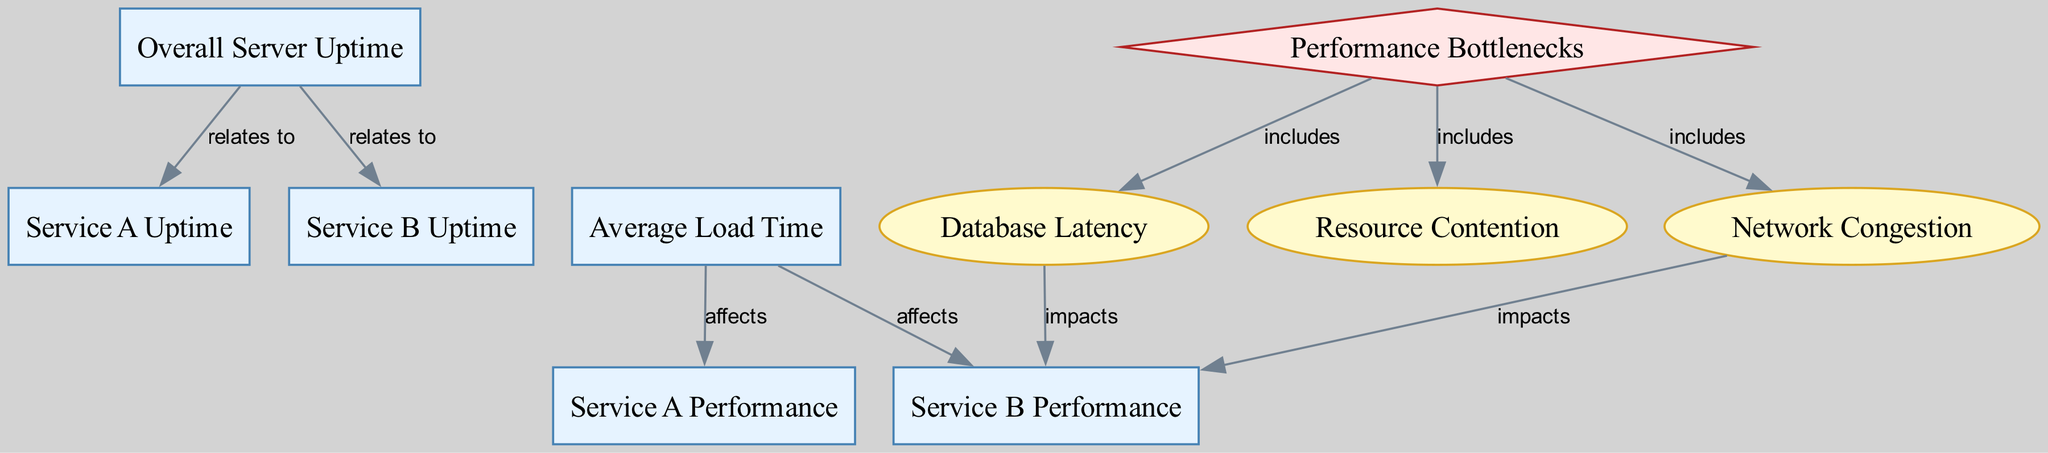What is the uptime percentage for Service A? The diagram contains a node labeled "Service A Uptime," which represents the uptime percentage specifically for Service A. This information can be directly identified from the node itself.
Answer: Service A Uptime What is overall server uptime? The "Overall Server Uptime" node provides the percentage of time the server is operational. The value for this metric can be found directly in the node labeled "Overall Server Uptime."
Answer: Overall Server Uptime How many performance bottlenecks are identified? The section "Performance Bottlenecks" has three identified issues that fall under it: Database Latency, Resource Contention, and Network Congestion. Therefore, the count of performance bottlenecks is determined by the number of issues listed.
Answer: Three Which service has a performance impacted by database latency? The diagram shows that "Database Latency" impacts "Service B Performance" as represented by the directed edge labeled "impacts". Thus, the description indicates that database latency affects the performance metrics for Service B.
Answer: Service B What is the relationship between average load time and Service A performance? There is an edge labeled "affects" connecting the "Average Load Time" node to the "Service A Performance" node. This indicates that the average load time directly affects the average response time for Service A.
Answer: Affects Which issue is related to network delays? The node labeled "Network Congestion" directly corresponds to the identified issue causing delays. It is explicitly outlined in the diagram, showing its role in impacting performance.
Answer: Network Congestion How many nodes represent performance metrics? The diagram contains five nodes that serve as performance metrics: "Overall Server Uptime," "Service A Uptime," "Service B Uptime," "Average Load Time," "Service A Performance," and "Service B Performance." To find the total, one counts these specific nodes.
Answer: Five What is the effect of resource contention on service performance? "Resource Contention" is identified as an issue in the diagram and impacts "Service B Performance" based on the directed edge labeled "impacts." This shows that resource contention leads to performance degradation for Service B.
Answer: Service B Performance Which services are directly related to overall server uptime? The diagram depicts edges connecting "Overall Server Uptime" to both "Service A Uptime" and "Service B Uptime." This indicates that the overall server uptime metric relates to the uptime of both services.
Answer: Service A Uptime and Service B Uptime 